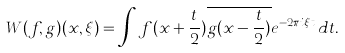<formula> <loc_0><loc_0><loc_500><loc_500>W ( f , g ) ( x , \xi ) = \int f ( x + \frac { t } 2 ) \overline { g ( x - \frac { t } 2 ) } e ^ { - 2 \pi i \xi t } \, d t .</formula> 